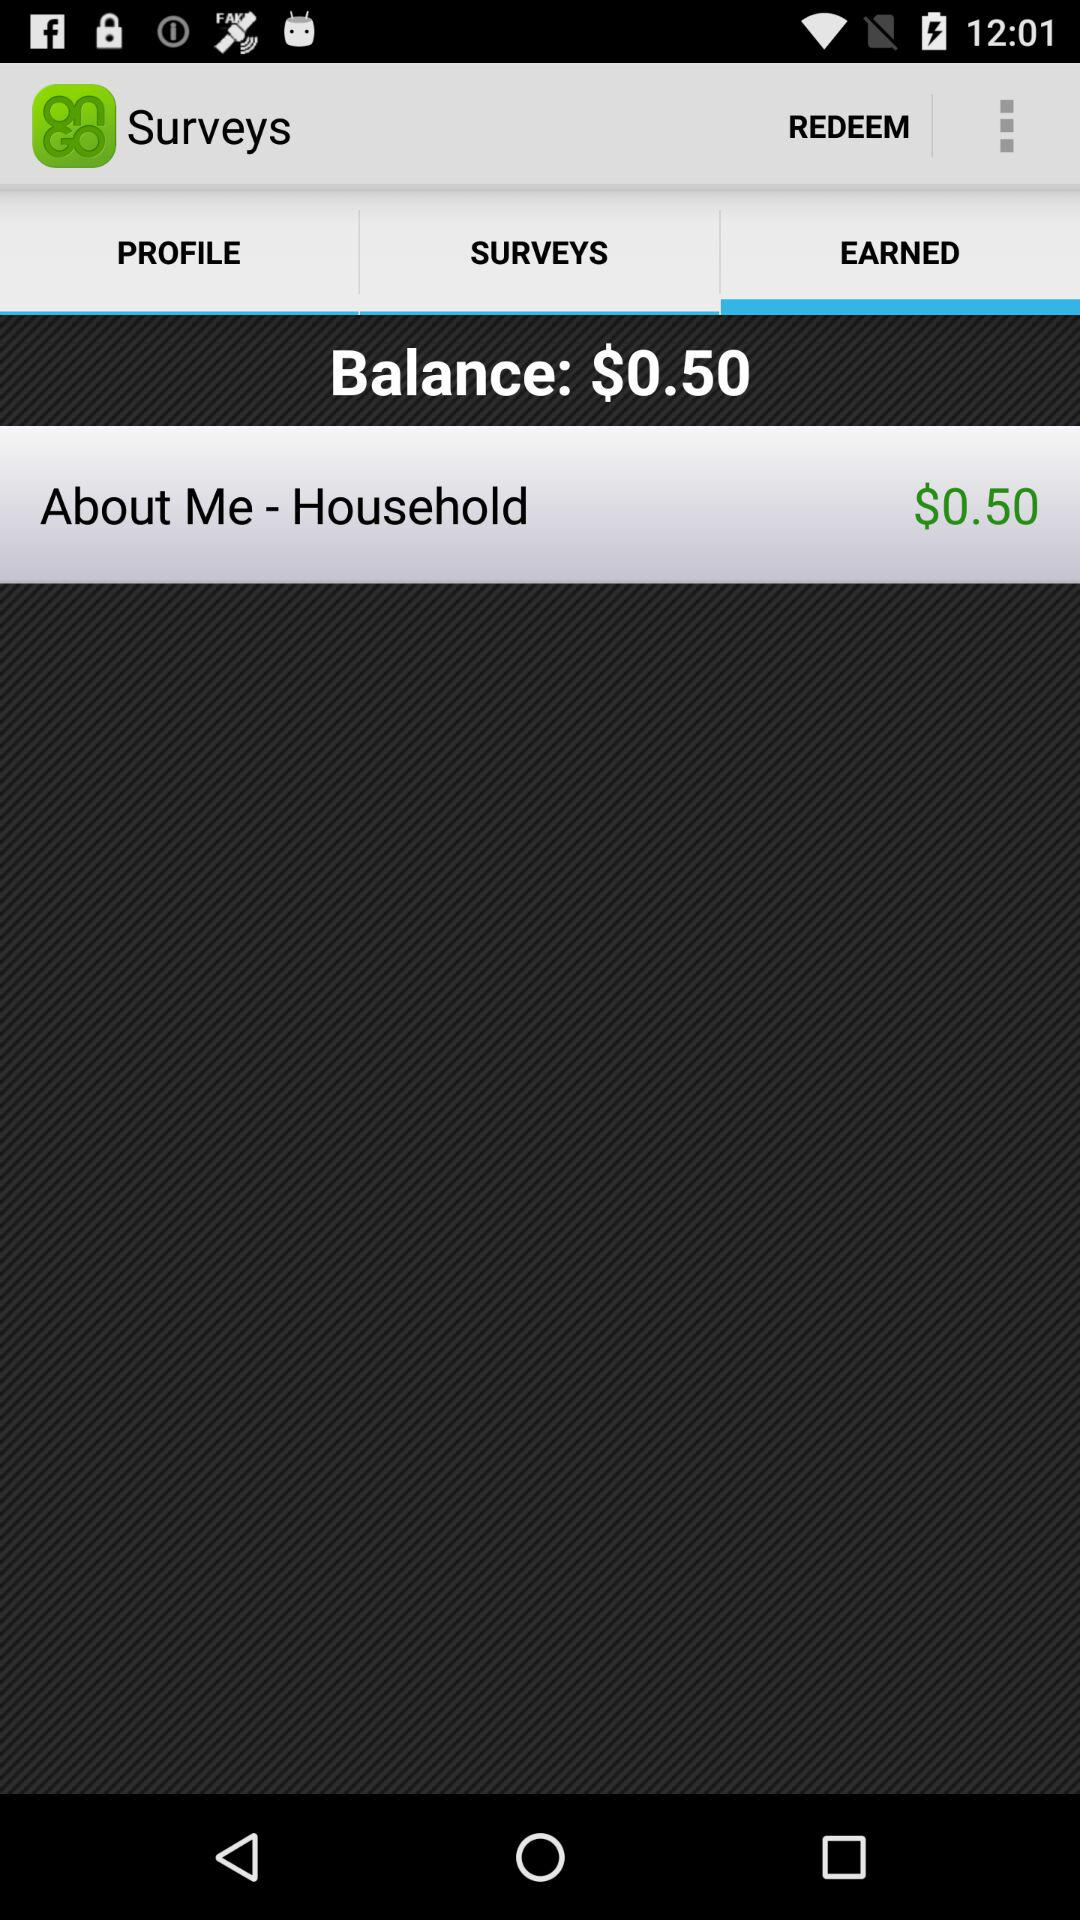How many items are in "PROFILE"?
When the provided information is insufficient, respond with <no answer>. <no answer> 